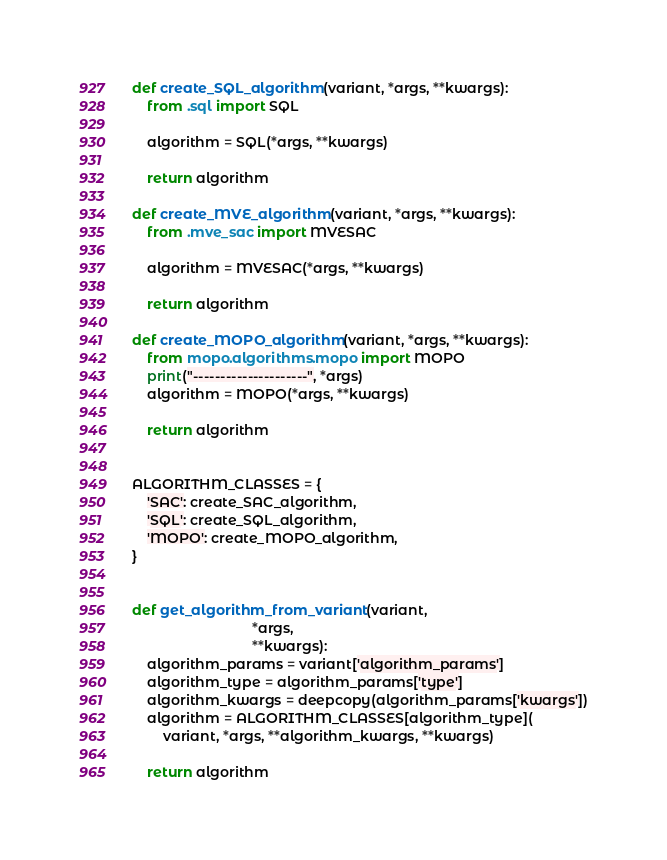<code> <loc_0><loc_0><loc_500><loc_500><_Python_>

def create_SQL_algorithm(variant, *args, **kwargs):
    from .sql import SQL

    algorithm = SQL(*args, **kwargs)

    return algorithm

def create_MVE_algorithm(variant, *args, **kwargs):
    from .mve_sac import MVESAC

    algorithm = MVESAC(*args, **kwargs)

    return algorithm

def create_MOPO_algorithm(variant, *args, **kwargs):
    from mopo.algorithms.mopo import MOPO
    print("---------------------", *args)
    algorithm = MOPO(*args, **kwargs)

    return algorithm


ALGORITHM_CLASSES = {
    'SAC': create_SAC_algorithm,
    'SQL': create_SQL_algorithm,
    'MOPO': create_MOPO_algorithm,
}


def get_algorithm_from_variant(variant,
                               *args,
                               **kwargs):
    algorithm_params = variant['algorithm_params']
    algorithm_type = algorithm_params['type']
    algorithm_kwargs = deepcopy(algorithm_params['kwargs'])
    algorithm = ALGORITHM_CLASSES[algorithm_type](
        variant, *args, **algorithm_kwargs, **kwargs)

    return algorithm
</code> 